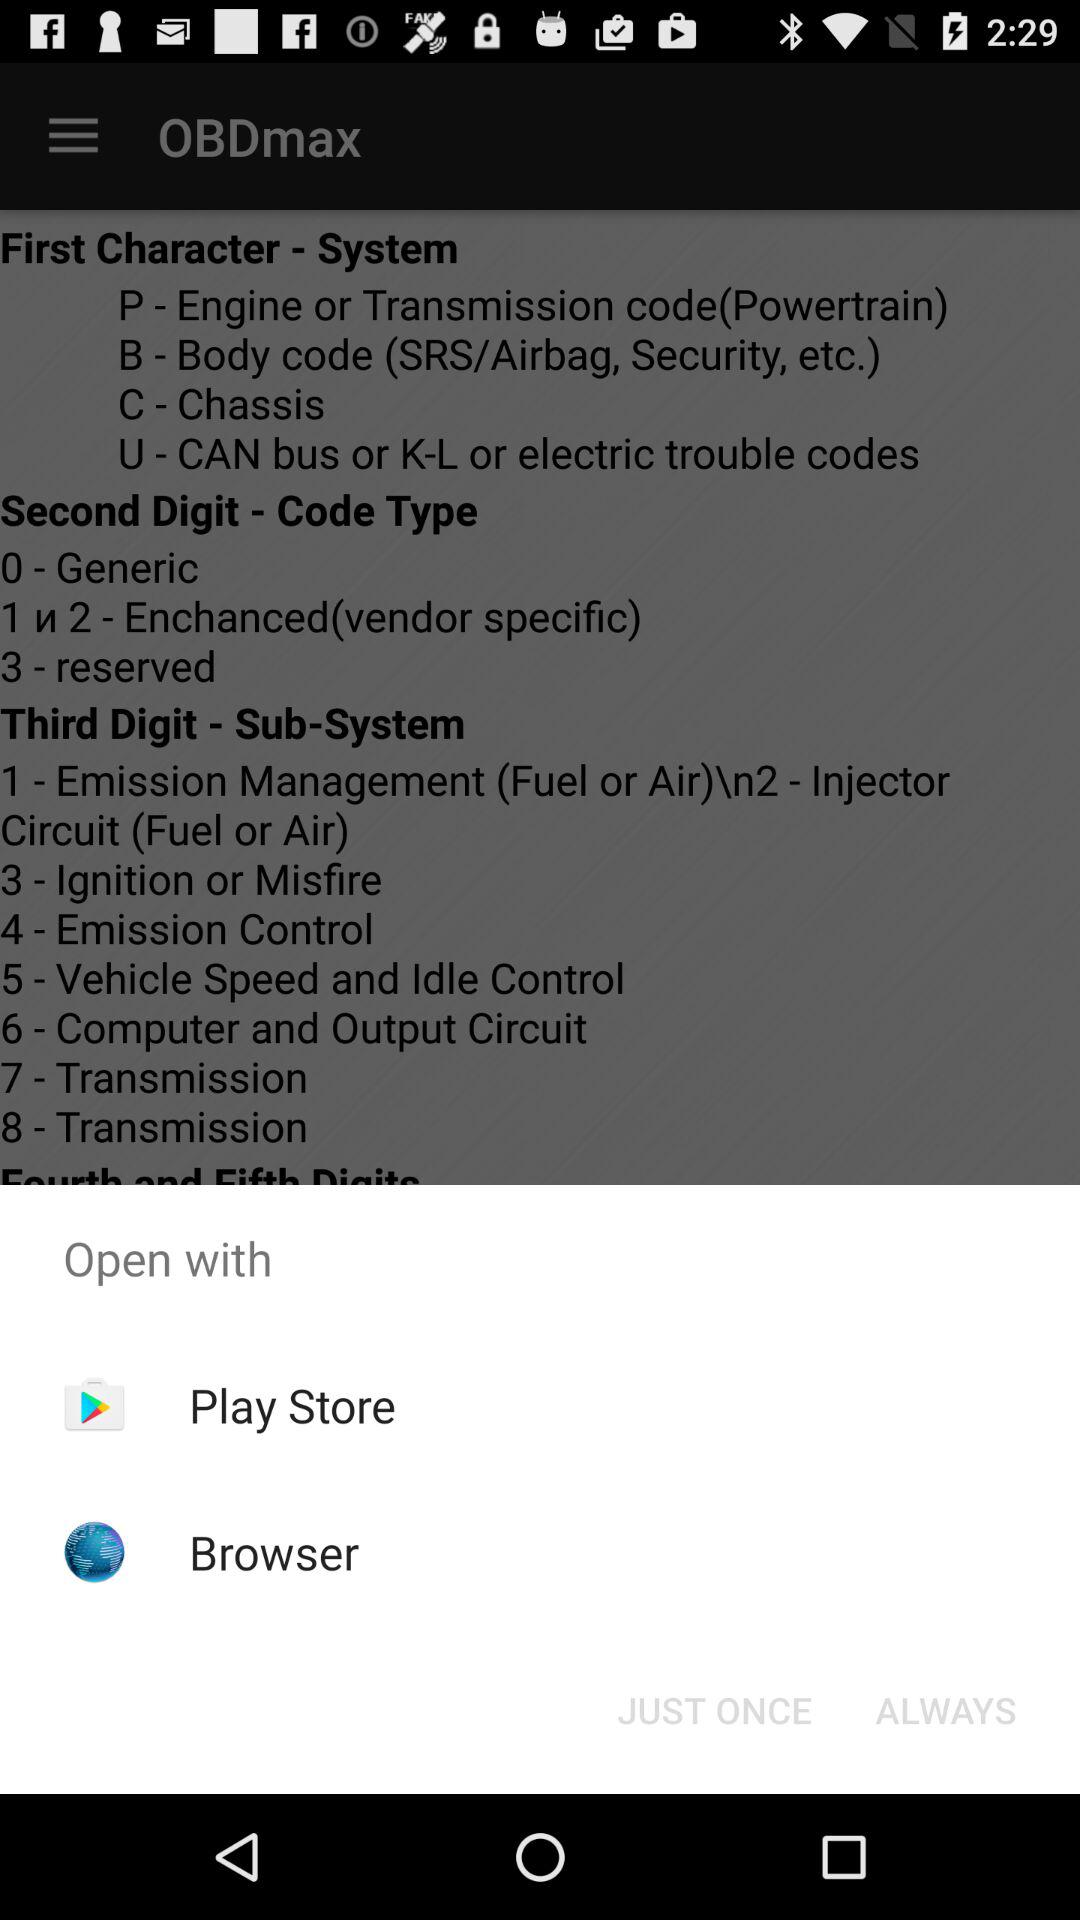Who is this application powered by?
When the provided information is insufficient, respond with <no answer>. <no answer> 